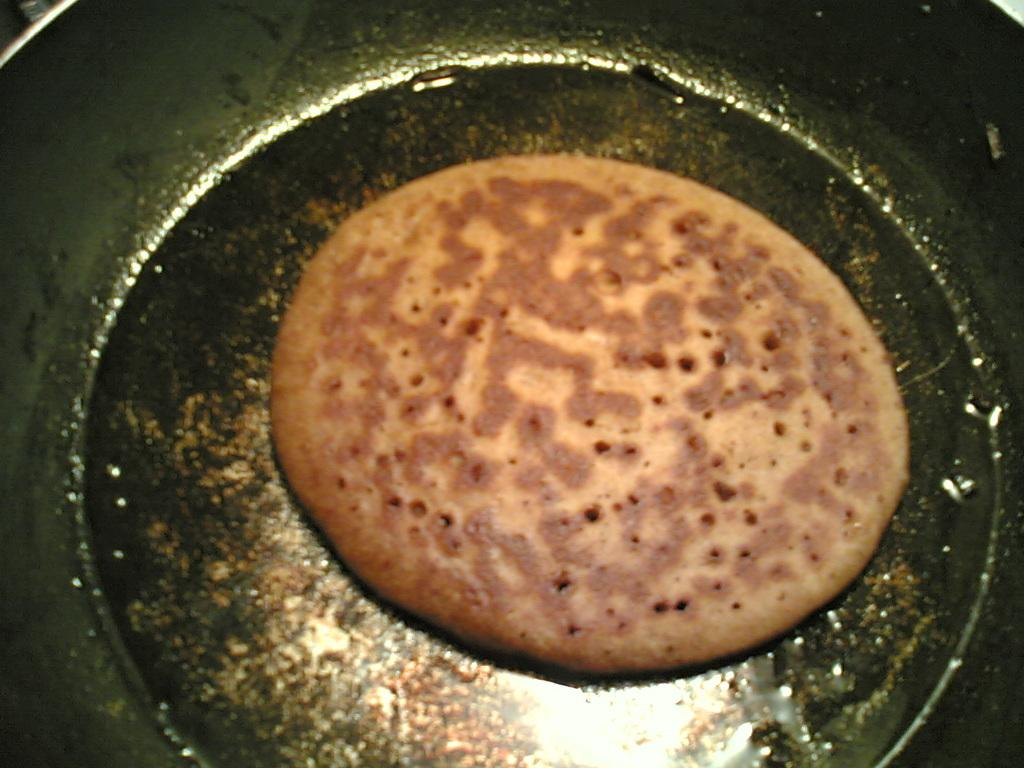What is present in the pan in the image? There is food in the pan in the image. Can you see a church in the background of the image? There is no mention of a church or any background in the provided fact, so it cannot be determined from the image. 